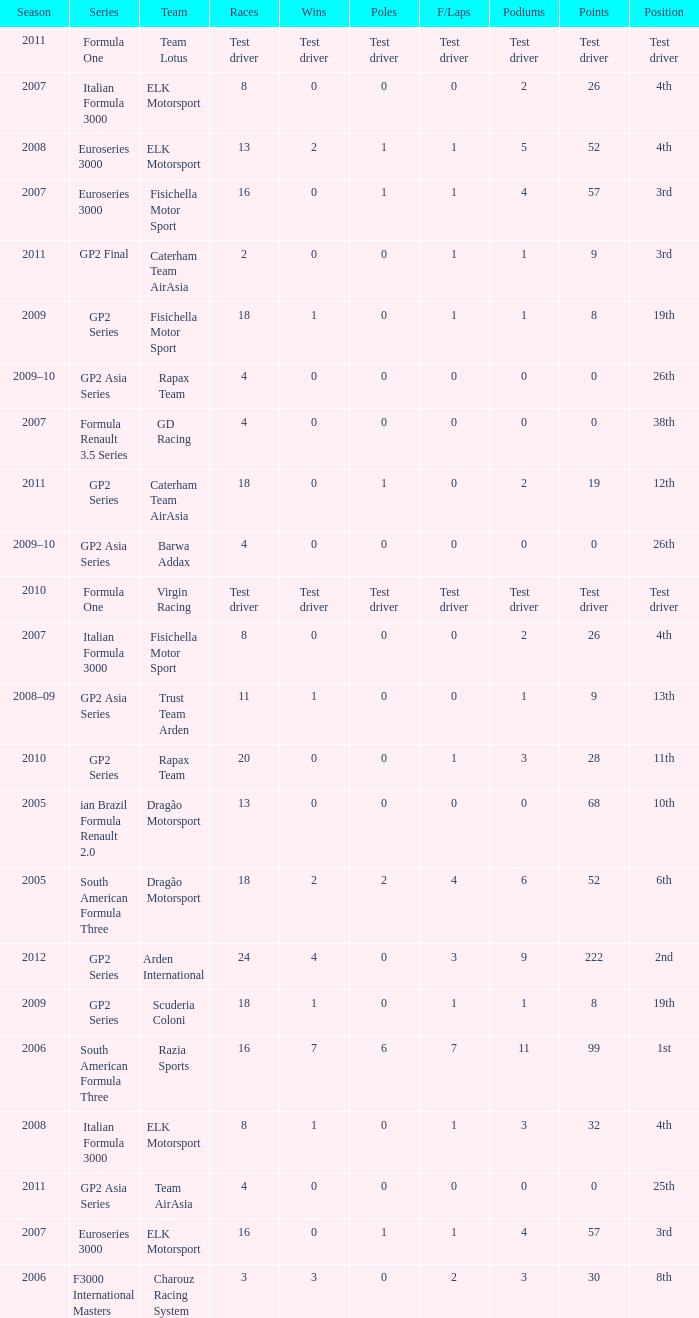What was his position in 2009 with 1 win? 19th, 19th. 